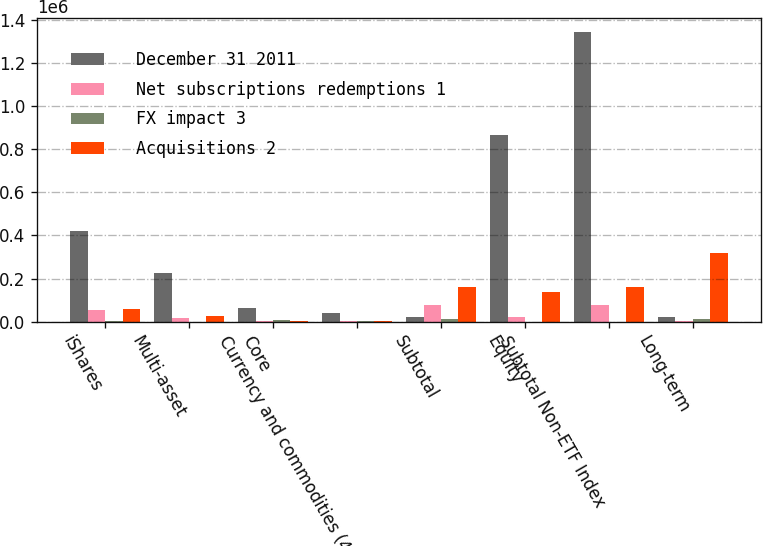<chart> <loc_0><loc_0><loc_500><loc_500><stacked_bar_chart><ecel><fcel>iShares<fcel>Multi-asset<fcel>Core<fcel>Currency and commodities (4)<fcel>Subtotal<fcel>Equity<fcel>Subtotal Non-ETF Index<fcel>Long-term<nl><fcel>December 31 2011<fcel>419651<fcel>225170<fcel>63647<fcel>41301<fcel>22113<fcel>865299<fcel>1.34442e+06<fcel>22113<nl><fcel>Net subscriptions redemptions 1<fcel>52973<fcel>15817<fcel>3922<fcel>1547<fcel>74887<fcel>19154<fcel>77352<fcel>2465<nl><fcel>FX impact 3<fcel>3517<fcel>78<fcel>6166<fcel>860<fcel>13647<fcel>95<fcel>95<fcel>13742<nl><fcel>Acquisitions 2<fcel>56433<fcel>25072<fcel>2266<fcel>1307<fcel>160477<fcel>138730<fcel>159721<fcel>320198<nl></chart> 